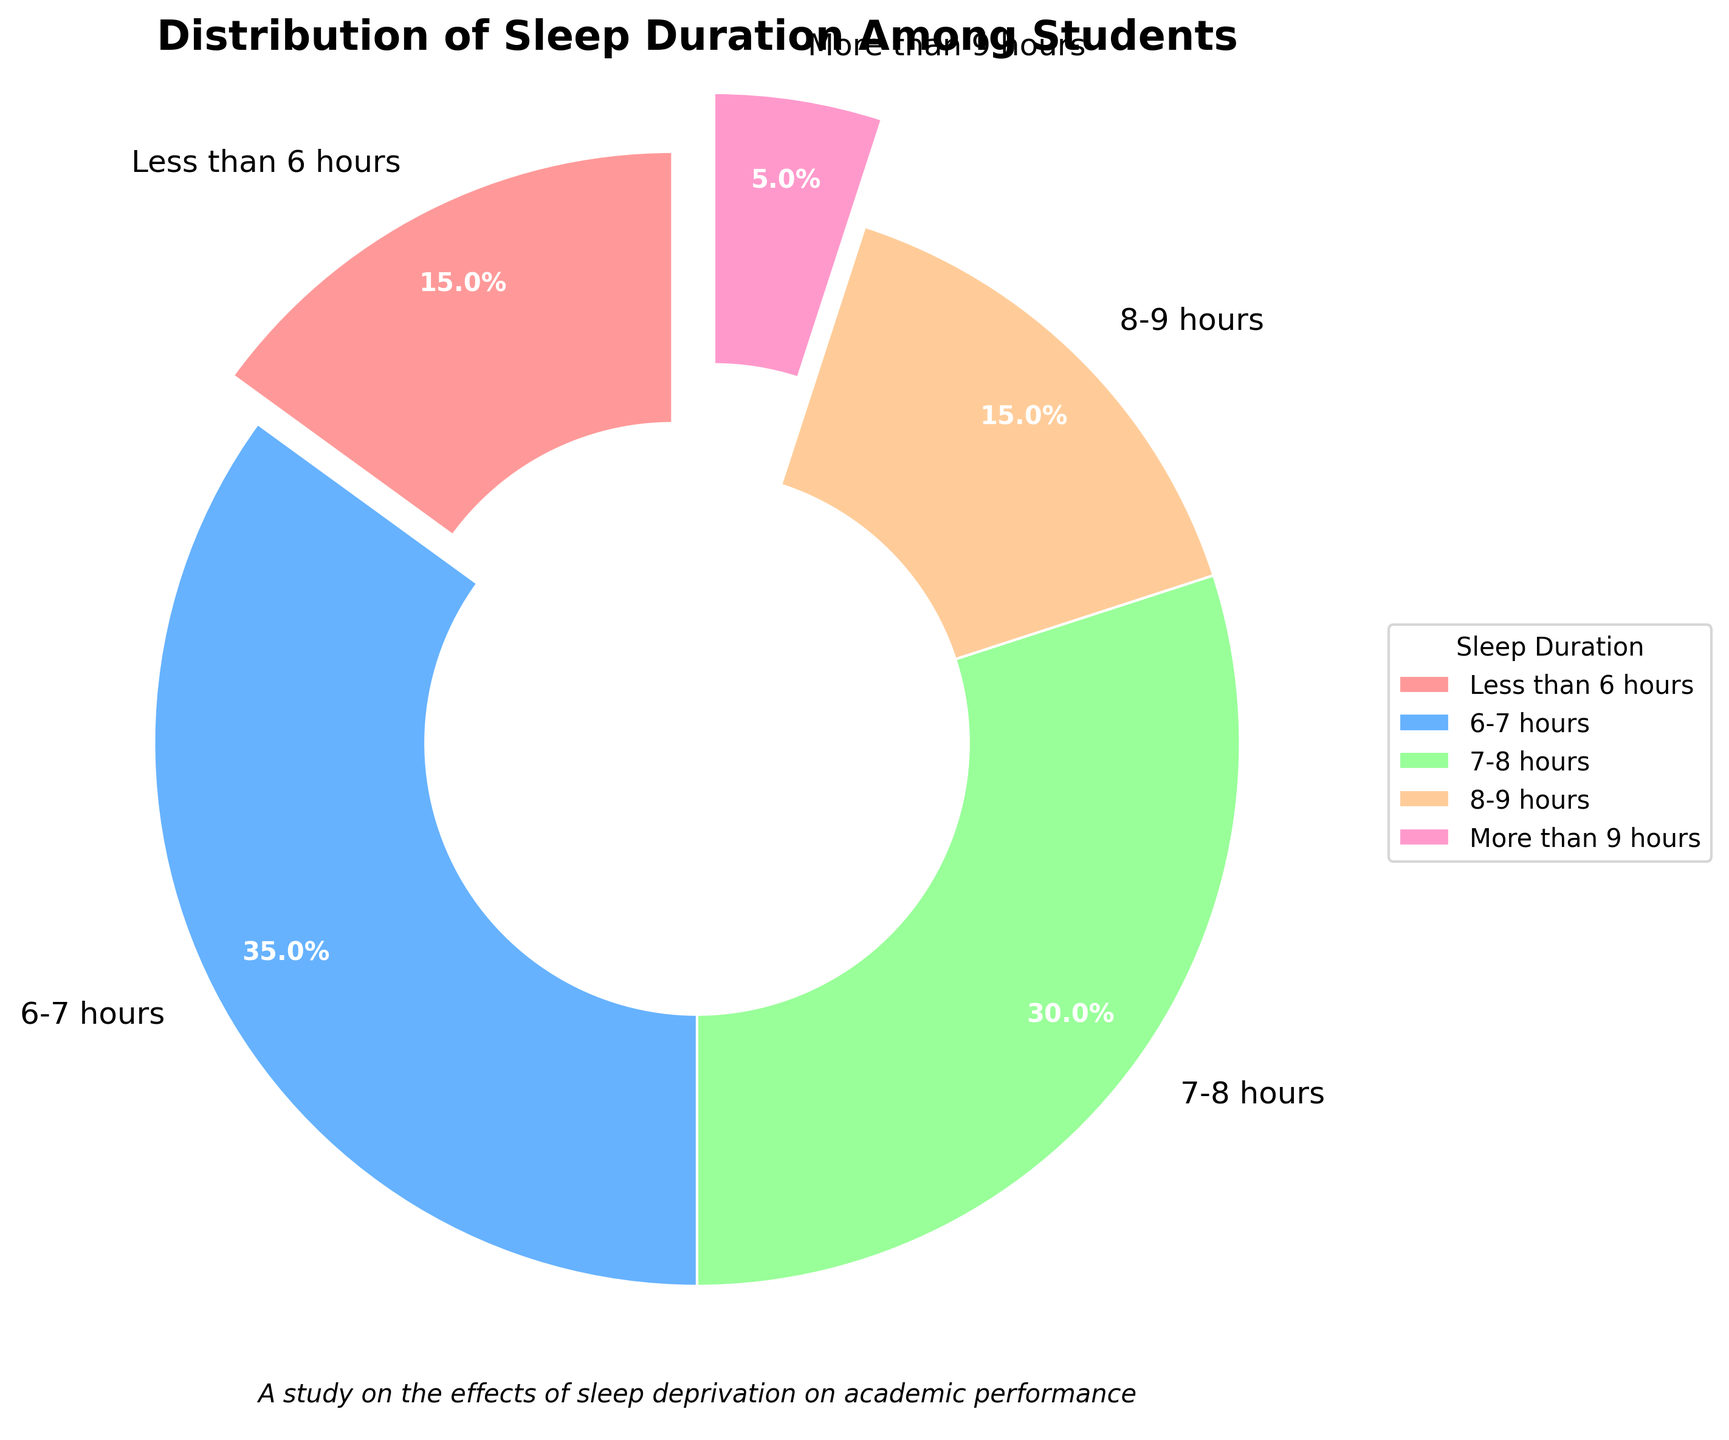How many students sleep less than 6 hours compared to those who sleep more than 9 hours? The pie chart shows that 15% of students sleep less than 6 hours, and 5% of students sleep more than 9 hours. Comparing these, there are 3 times as many students sleeping less than 6 hours as those sleeping more than 9 hours.
Answer: 3 times What percentage of students get 6-8 hours of sleep? To find this, add the percentages of students who sleep 6-7 hours and those who sleep 7-8 hours. This is 35% + 30% = 65%.
Answer: 65% Which sleep duration category is the most common among students? By looking at the largest segment in the pie chart, the 6-7 hours category has the highest percentage at 35%, indicating it's the most common sleep duration.
Answer: 6-7 hours How does the percentage of students getting less than 6 hours of sleep compare to those getting 8-9 hours of sleep? The chart shows that both categories have an equal percentage of 15%.
Answer: Equal Of the students who sleep between 6-8 hours, what is the ratio of those who sleep 6-7 hours to those who sleep 7-8 hours? The percentages are 35% for 6-7 hours and 30% for 7-8 hours. The ratio is 35:30, which simplifies to 7:6.
Answer: 7:6 What is the combined percentage of students who sleep either less than 6 hours or more than 9 hours? Add the percentages of these two categories: 15% (less than 6 hours) + 5% (more than 9 hours) = 20%.
Answer: 20% Which category has the smallest percentage of students, and what color represents it on the pie chart? The pie chart shows that the category 'More than 9 hours' has the smallest percentage (5%) and is represented by a pink color.
Answer: More than 9 hours, pink What is the percentage difference between students who sleep 7-8 hours and those who sleep 8-9 hours? Subtract the percentage of students who sleep 8-9 hours (15%) from those who sleep 7-8 hours (30%): 30% - 15% = 15%.
Answer: 15% Given that students who sleep 6-7 hours form the largest group, by how much does their percentage exceed the group that sleeps less than 6 hours? The percentage for 6-7 hours is 35%, and for less than 6 hours, it's 15%. The difference is 35% - 15% = 20%.
Answer: 20% If you consider students getting either 7-8 hours or 8-9 hours of sleep, what fraction of the student population do they represent? Add the percentages of the two categories: 30% (7-8 hours) + 15% (8-9 hours) = 45%. Thus, they represent 45% of the student population.
Answer: 45% 